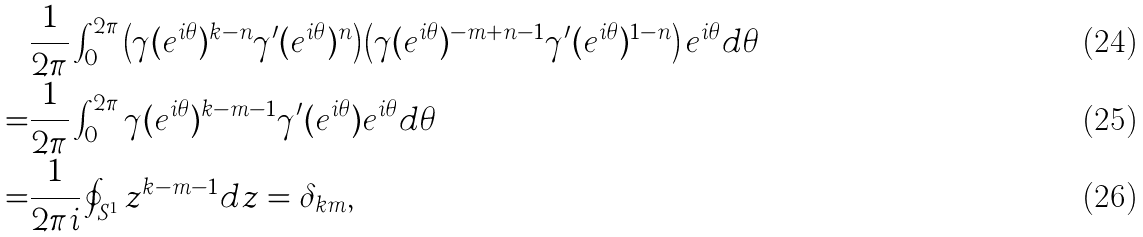<formula> <loc_0><loc_0><loc_500><loc_500>& \frac { 1 } { 2 \pi } \int _ { 0 } ^ { 2 \pi } \left ( \gamma ( e ^ { i \theta } ) ^ { k - n } \gamma ^ { \prime } ( e ^ { i \theta } ) ^ { n } \right ) \left ( \gamma ( e ^ { i \theta } ) ^ { - m + n - 1 } \gamma ^ { \prime } ( e ^ { i \theta } ) ^ { 1 - n } \right ) e ^ { i \theta } d \theta \\ = & \frac { 1 } { 2 \pi } \int _ { 0 } ^ { 2 \pi } \gamma ( e ^ { i \theta } ) ^ { k - m - 1 } \gamma ^ { \prime } ( e ^ { i \theta } ) e ^ { i \theta } d \theta \\ = & \frac { 1 } { 2 \pi i } \oint _ { S ^ { 1 } } z ^ { k - m - 1 } d z = \delta _ { k m } ,</formula> 